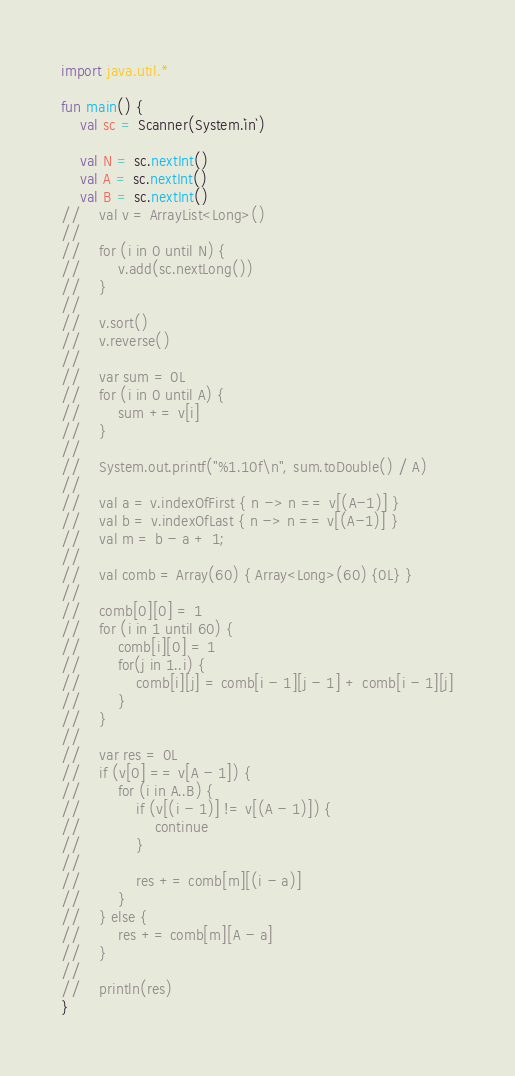Convert code to text. <code><loc_0><loc_0><loc_500><loc_500><_Kotlin_>import java.util.*

fun main() {
    val sc = Scanner(System.`in`)

    val N = sc.nextInt()
    val A = sc.nextInt()
    val B = sc.nextInt()
//    val v = ArrayList<Long>()
//
//    for (i in 0 until N) {
//        v.add(sc.nextLong())
//    }
//
//    v.sort()
//    v.reverse()
//
//    var sum = 0L
//    for (i in 0 until A) {
//        sum += v[i]
//    }
//
//    System.out.printf("%1.10f\n", sum.toDouble() / A)
//
//    val a = v.indexOfFirst { n -> n == v[(A-1)] }
//    val b = v.indexOfLast { n -> n == v[(A-1)] }
//    val m = b - a + 1;
//
//    val comb = Array(60) { Array<Long>(60) {0L} }
//
//    comb[0][0] = 1
//    for (i in 1 until 60) {
//        comb[i][0] = 1
//        for(j in 1..i) {
//            comb[i][j] = comb[i - 1][j - 1] + comb[i - 1][j]
//        }
//    }
//
//    var res = 0L
//    if (v[0] == v[A - 1]) {
//        for (i in A..B) {
//            if (v[(i - 1)] != v[(A - 1)]) {
//                continue
//            }
//
//            res += comb[m][(i - a)]
//        }
//    } else {
//        res += comb[m][A - a]
//    }
//
//    println(res)
}</code> 